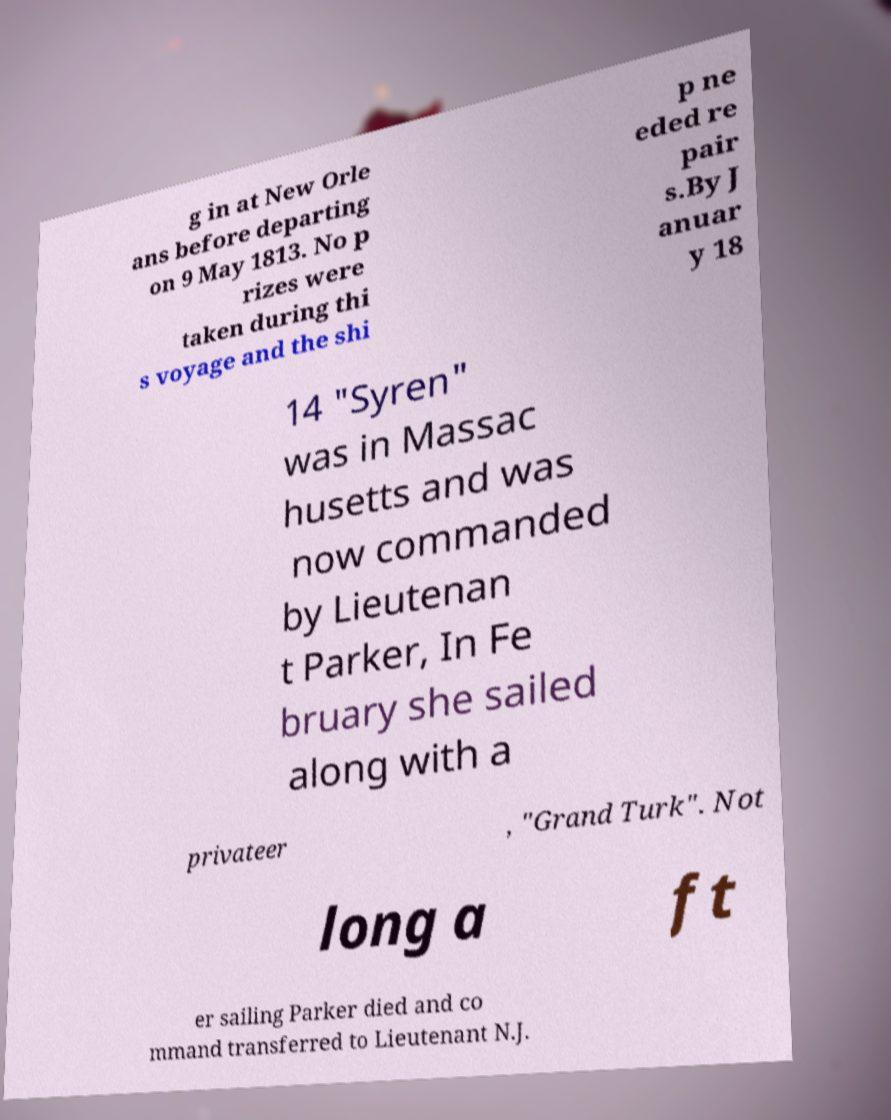I need the written content from this picture converted into text. Can you do that? g in at New Orle ans before departing on 9 May 1813. No p rizes were taken during thi s voyage and the shi p ne eded re pair s.By J anuar y 18 14 "Syren" was in Massac husetts and was now commanded by Lieutenan t Parker, In Fe bruary she sailed along with a privateer , "Grand Turk". Not long a ft er sailing Parker died and co mmand transferred to Lieutenant N.J. 